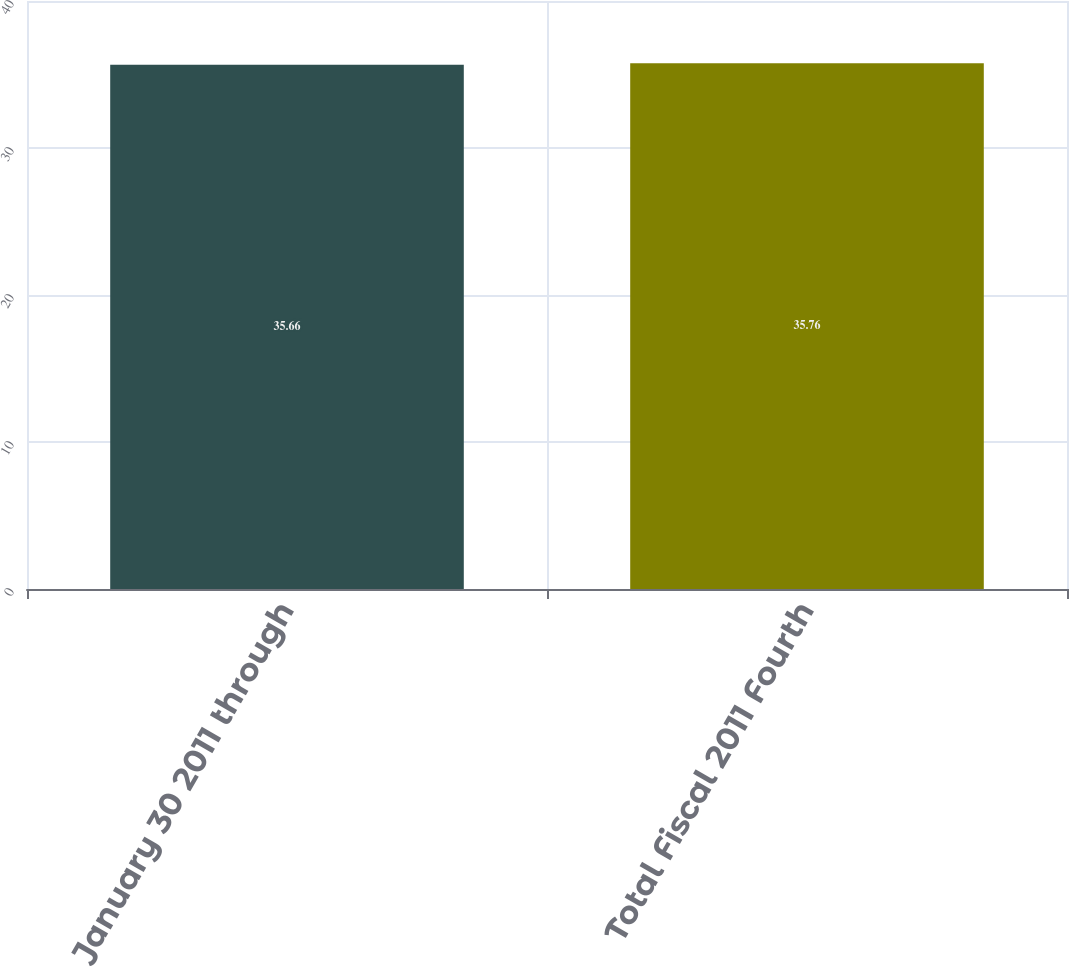Convert chart to OTSL. <chart><loc_0><loc_0><loc_500><loc_500><bar_chart><fcel>January 30 2011 through<fcel>Total Fiscal 2011 Fourth<nl><fcel>35.66<fcel>35.76<nl></chart> 